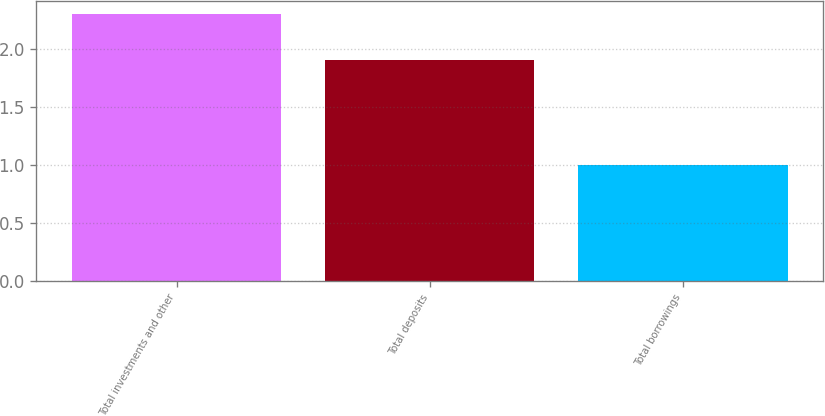<chart> <loc_0><loc_0><loc_500><loc_500><bar_chart><fcel>Total investments and other<fcel>Total deposits<fcel>Total borrowings<nl><fcel>2.3<fcel>1.9<fcel>1<nl></chart> 